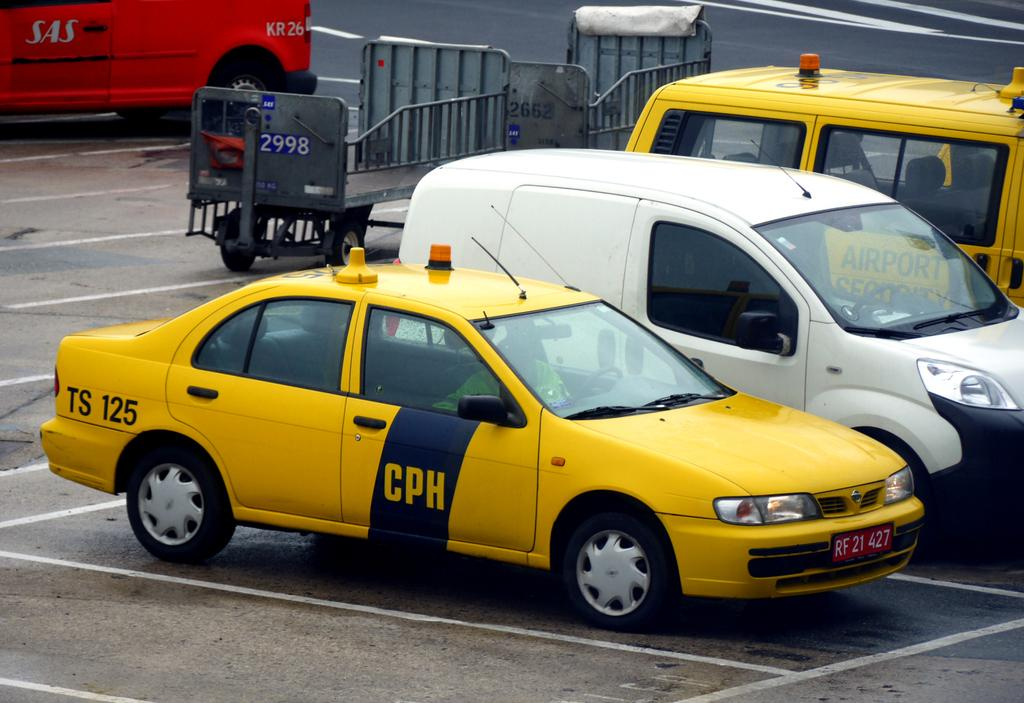<image>
Share a concise interpretation of the image provided. A taxi cab has the letters "CPH" on its door. 